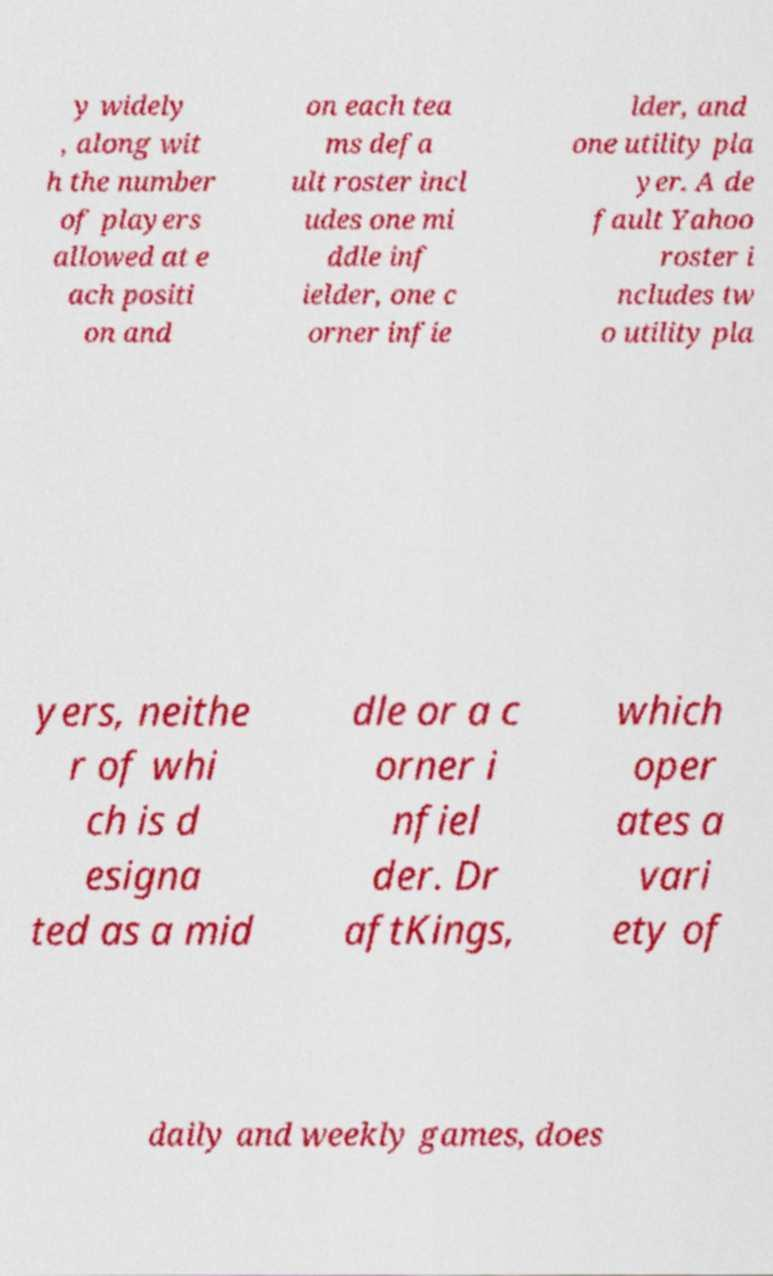Can you read and provide the text displayed in the image?This photo seems to have some interesting text. Can you extract and type it out for me? y widely , along wit h the number of players allowed at e ach positi on and on each tea ms defa ult roster incl udes one mi ddle inf ielder, one c orner infie lder, and one utility pla yer. A de fault Yahoo roster i ncludes tw o utility pla yers, neithe r of whi ch is d esigna ted as a mid dle or a c orner i nfiel der. Dr aftKings, which oper ates a vari ety of daily and weekly games, does 